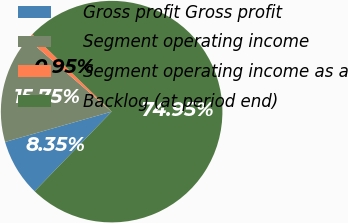Convert chart. <chart><loc_0><loc_0><loc_500><loc_500><pie_chart><fcel>Gross profit Gross profit<fcel>Segment operating income<fcel>Segment operating income as a<fcel>Backlog (at period end)<nl><fcel>8.35%<fcel>15.75%<fcel>0.95%<fcel>74.95%<nl></chart> 